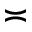<formula> <loc_0><loc_0><loc_500><loc_500>\asymp</formula> 